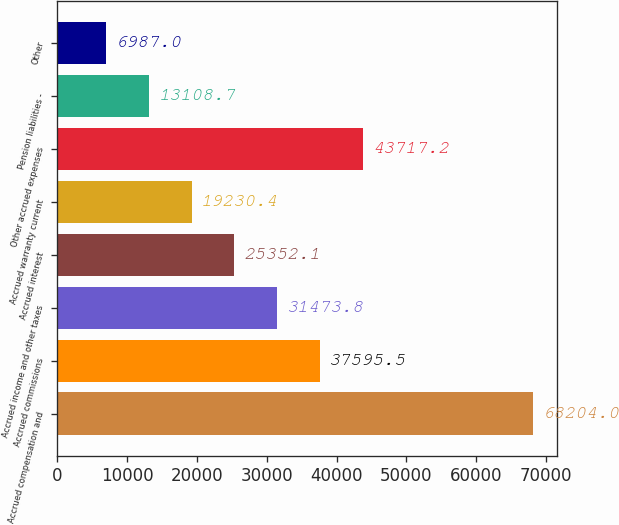Convert chart. <chart><loc_0><loc_0><loc_500><loc_500><bar_chart><fcel>Accrued compensation and<fcel>Accrued commissions<fcel>Accrued income and other taxes<fcel>Accrued interest<fcel>Accrued warranty current<fcel>Other accrued expenses<fcel>Pension liabilities -<fcel>Other<nl><fcel>68204<fcel>37595.5<fcel>31473.8<fcel>25352.1<fcel>19230.4<fcel>43717.2<fcel>13108.7<fcel>6987<nl></chart> 